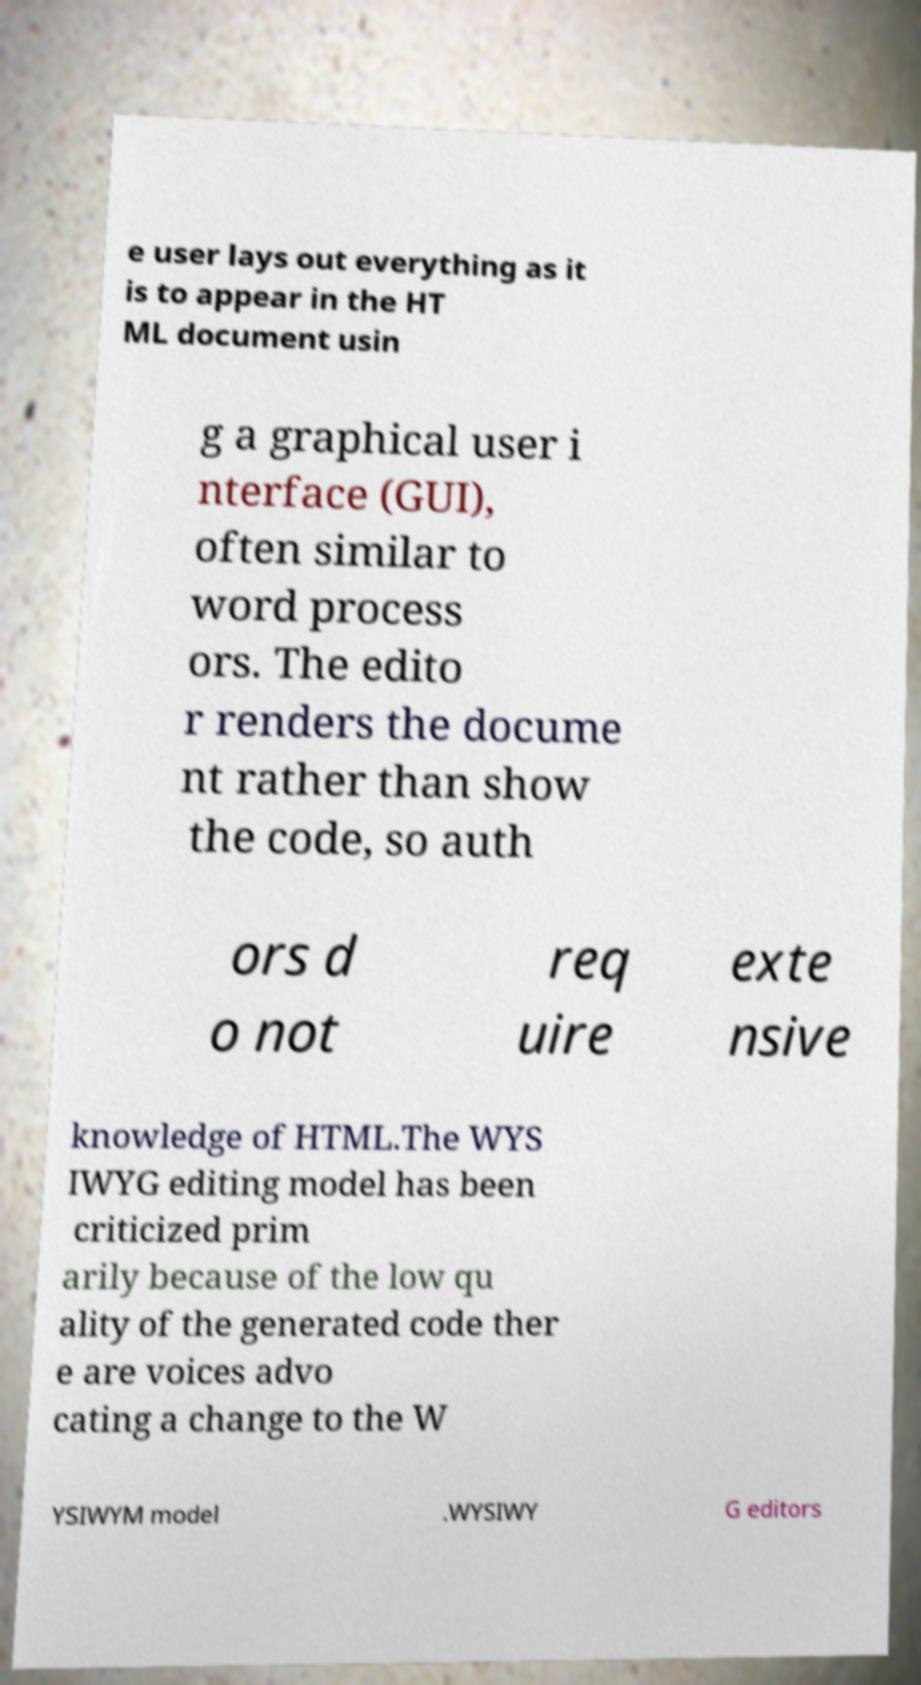Can you accurately transcribe the text from the provided image for me? e user lays out everything as it is to appear in the HT ML document usin g a graphical user i nterface (GUI), often similar to word process ors. The edito r renders the docume nt rather than show the code, so auth ors d o not req uire exte nsive knowledge of HTML.The WYS IWYG editing model has been criticized prim arily because of the low qu ality of the generated code ther e are voices advo cating a change to the W YSIWYM model .WYSIWY G editors 